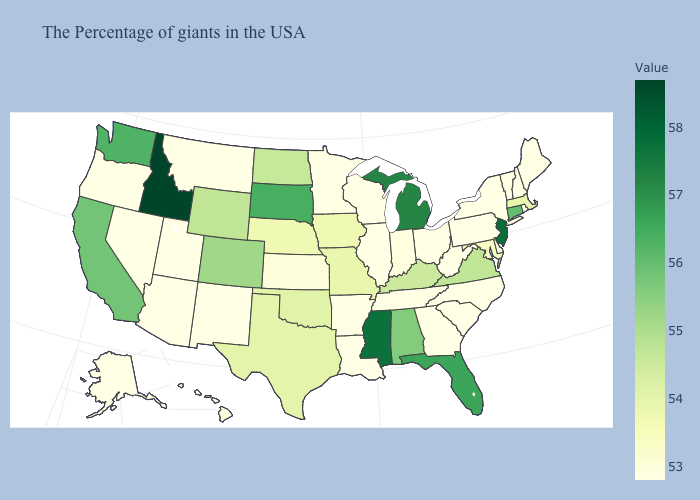Does Pennsylvania have the lowest value in the Northeast?
Write a very short answer. Yes. Does Colorado have the lowest value in the USA?
Concise answer only. No. Does Michigan have the lowest value in the USA?
Quick response, please. No. Does Arkansas have the lowest value in the South?
Write a very short answer. Yes. Does Indiana have the lowest value in the MidWest?
Write a very short answer. No. Which states have the lowest value in the MidWest?
Give a very brief answer. Ohio, Wisconsin, Illinois, Minnesota. Among the states that border Alabama , does Georgia have the lowest value?
Write a very short answer. Yes. Does Wyoming have the lowest value in the USA?
Be succinct. No. Among the states that border Nebraska , which have the highest value?
Concise answer only. South Dakota. 